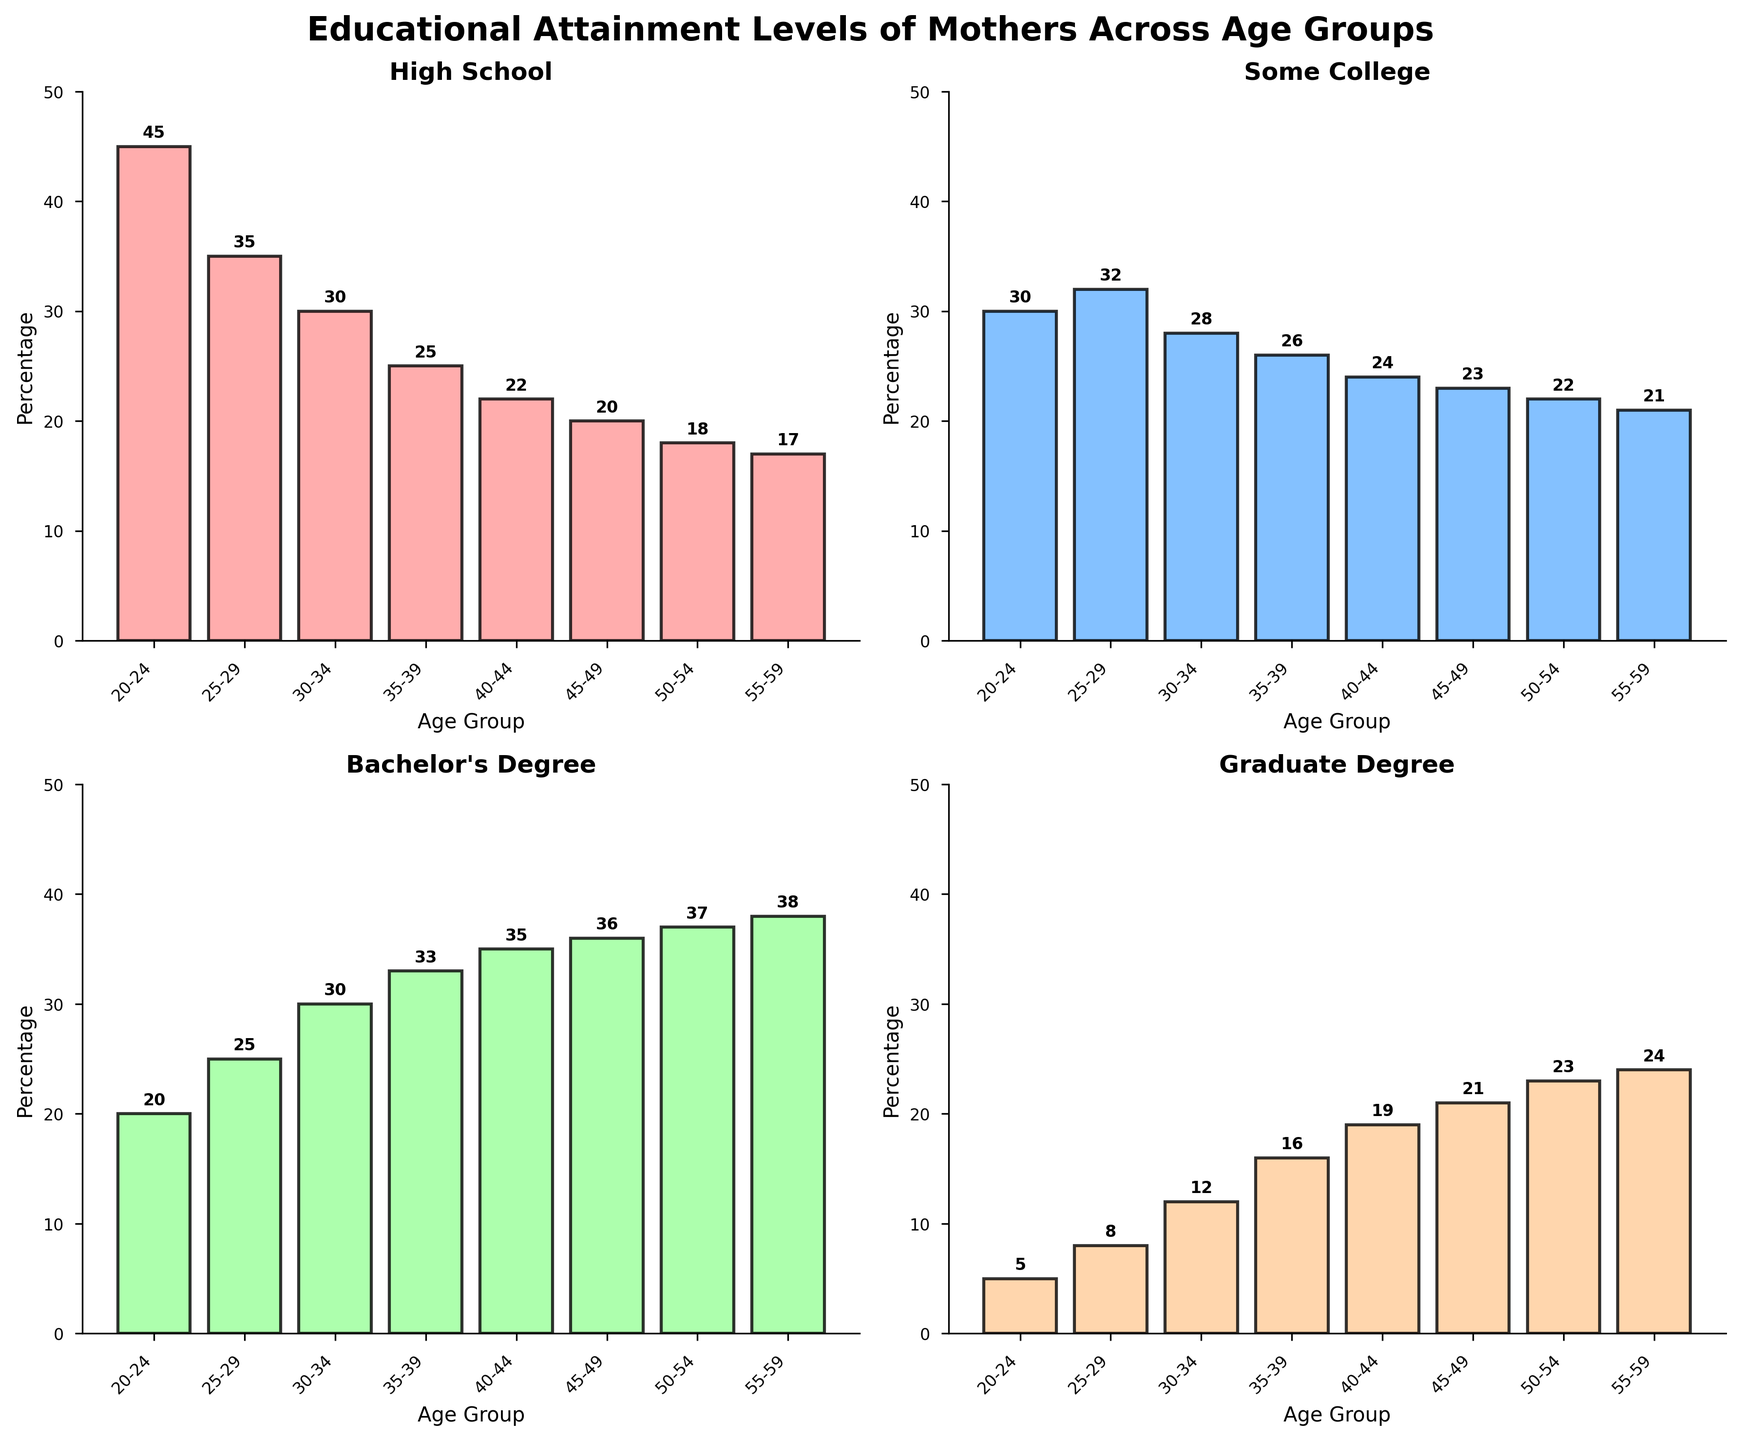Which age group has the highest percentage of mothers with a Bachelor's Degree? The subplot for a Bachelor's Degree shows the highest bar corresponds to the '55-59' age group.
Answer: 55-59 What is the difference in percentage between mothers with a High School education in the 20-24 age group and those in the 45-49 age group? The plot shows that the percentage for the 20-24 age group is 45%, and for the 45-49 age group, it is 20%. The difference is 45% - 20% = 25%.
Answer: 25% Among the age groups, which one has the smallest percentage of mothers with a Graduate Degree? The subplot for a Graduate Degree shows that the smallest bar corresponds to the '20-24' age group.
Answer: 20-24 For mothers in the age group 35-39, what are the average percentages across all educational attainment levels? The percentages for the 35-39 age group are 25%, 26%, 33%, and 16%. The average is calculated as (25 + 26 + 33 + 16) / 4 = 25%.
Answer: 25% Between the age groups 30-34 and 40-44, which one has a higher percentage of mothers with Some College education, and by how much? The subplot for Some College education shows that the 30-34 age group has 28%, and the 40-44 age group has 24%. The difference is 28% - 24% = 4%.
Answer: 30-34, 4% What is the sum of the percentages of mothers with a High School education across all age groups? The percentages for High School education are 45, 35, 30, 25, 22, 20, 18, and 17. The sum is 45 + 35 + 30 + 25 + 22 + 20 + 18 + 17 = 212.
Answer: 212 Which educational attainment level shows the most consistent trend in percentages as the age increases? Observing all subplots, the percentages for Graduate Degree increase the most consistently with each higher age group.
Answer: Graduate Degree 